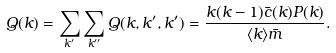Convert formula to latex. <formula><loc_0><loc_0><loc_500><loc_500>Q ( k ) = \sum _ { k ^ { \prime } } \sum _ { k ^ { \prime \prime } } Q ( k , k ^ { \prime } , k ^ { \prime } ) = \frac { k ( k - 1 ) \bar { c } ( k ) P ( k ) } { \langle k \rangle \bar { m } } .</formula> 